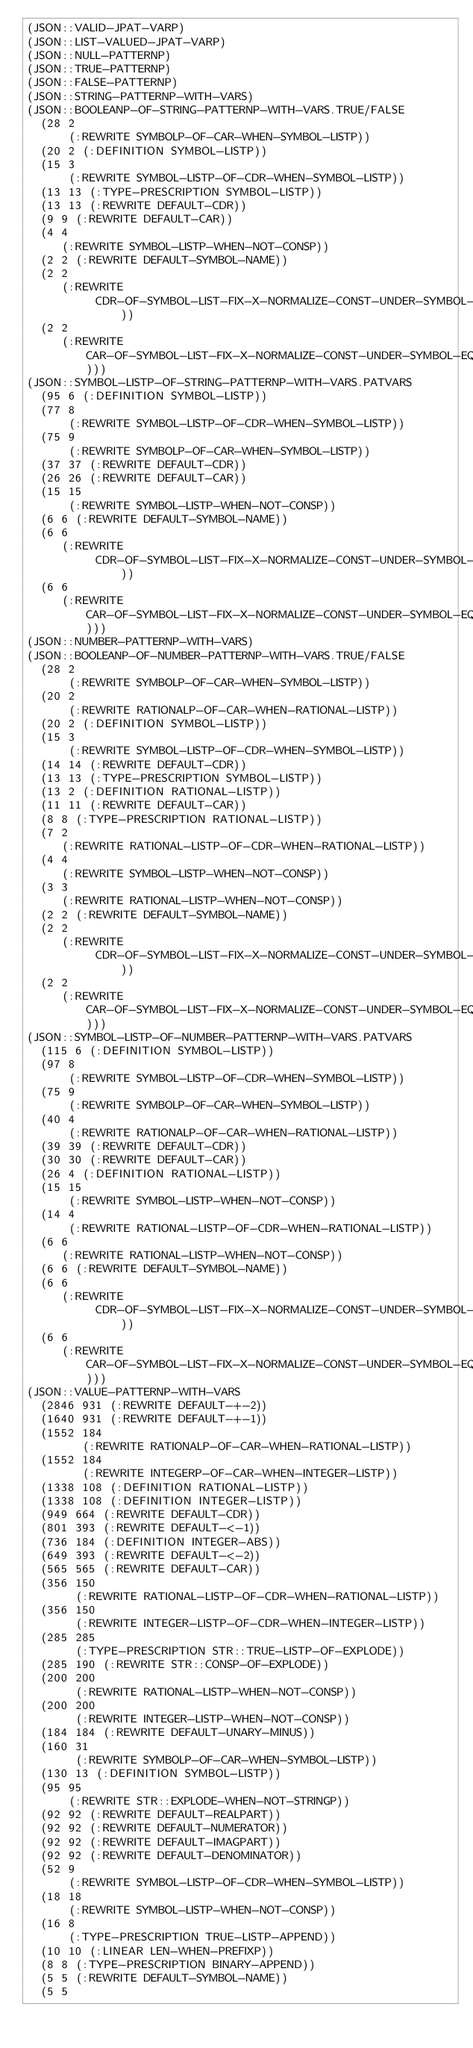Convert code to text. <code><loc_0><loc_0><loc_500><loc_500><_Lisp_>(JSON::VALID-JPAT-VARP)
(JSON::LIST-VALUED-JPAT-VARP)
(JSON::NULL-PATTERNP)
(JSON::TRUE-PATTERNP)
(JSON::FALSE-PATTERNP)
(JSON::STRING-PATTERNP-WITH-VARS)
(JSON::BOOLEANP-OF-STRING-PATTERNP-WITH-VARS.TRUE/FALSE
  (28 2
      (:REWRITE SYMBOLP-OF-CAR-WHEN-SYMBOL-LISTP))
  (20 2 (:DEFINITION SYMBOL-LISTP))
  (15 3
      (:REWRITE SYMBOL-LISTP-OF-CDR-WHEN-SYMBOL-LISTP))
  (13 13 (:TYPE-PRESCRIPTION SYMBOL-LISTP))
  (13 13 (:REWRITE DEFAULT-CDR))
  (9 9 (:REWRITE DEFAULT-CAR))
  (4 4
     (:REWRITE SYMBOL-LISTP-WHEN-NOT-CONSP))
  (2 2 (:REWRITE DEFAULT-SYMBOL-NAME))
  (2 2
     (:REWRITE
          CDR-OF-SYMBOL-LIST-FIX-X-NORMALIZE-CONST-UNDER-SYMBOL-LIST-EQUIV))
  (2 2
     (:REWRITE CAR-OF-SYMBOL-LIST-FIX-X-NORMALIZE-CONST-UNDER-SYMBOL-EQUIV)))
(JSON::SYMBOL-LISTP-OF-STRING-PATTERNP-WITH-VARS.PATVARS
  (95 6 (:DEFINITION SYMBOL-LISTP))
  (77 8
      (:REWRITE SYMBOL-LISTP-OF-CDR-WHEN-SYMBOL-LISTP))
  (75 9
      (:REWRITE SYMBOLP-OF-CAR-WHEN-SYMBOL-LISTP))
  (37 37 (:REWRITE DEFAULT-CDR))
  (26 26 (:REWRITE DEFAULT-CAR))
  (15 15
      (:REWRITE SYMBOL-LISTP-WHEN-NOT-CONSP))
  (6 6 (:REWRITE DEFAULT-SYMBOL-NAME))
  (6 6
     (:REWRITE
          CDR-OF-SYMBOL-LIST-FIX-X-NORMALIZE-CONST-UNDER-SYMBOL-LIST-EQUIV))
  (6 6
     (:REWRITE CAR-OF-SYMBOL-LIST-FIX-X-NORMALIZE-CONST-UNDER-SYMBOL-EQUIV)))
(JSON::NUMBER-PATTERNP-WITH-VARS)
(JSON::BOOLEANP-OF-NUMBER-PATTERNP-WITH-VARS.TRUE/FALSE
  (28 2
      (:REWRITE SYMBOLP-OF-CAR-WHEN-SYMBOL-LISTP))
  (20 2
      (:REWRITE RATIONALP-OF-CAR-WHEN-RATIONAL-LISTP))
  (20 2 (:DEFINITION SYMBOL-LISTP))
  (15 3
      (:REWRITE SYMBOL-LISTP-OF-CDR-WHEN-SYMBOL-LISTP))
  (14 14 (:REWRITE DEFAULT-CDR))
  (13 13 (:TYPE-PRESCRIPTION SYMBOL-LISTP))
  (13 2 (:DEFINITION RATIONAL-LISTP))
  (11 11 (:REWRITE DEFAULT-CAR))
  (8 8 (:TYPE-PRESCRIPTION RATIONAL-LISTP))
  (7 2
     (:REWRITE RATIONAL-LISTP-OF-CDR-WHEN-RATIONAL-LISTP))
  (4 4
     (:REWRITE SYMBOL-LISTP-WHEN-NOT-CONSP))
  (3 3
     (:REWRITE RATIONAL-LISTP-WHEN-NOT-CONSP))
  (2 2 (:REWRITE DEFAULT-SYMBOL-NAME))
  (2 2
     (:REWRITE
          CDR-OF-SYMBOL-LIST-FIX-X-NORMALIZE-CONST-UNDER-SYMBOL-LIST-EQUIV))
  (2 2
     (:REWRITE CAR-OF-SYMBOL-LIST-FIX-X-NORMALIZE-CONST-UNDER-SYMBOL-EQUIV)))
(JSON::SYMBOL-LISTP-OF-NUMBER-PATTERNP-WITH-VARS.PATVARS
  (115 6 (:DEFINITION SYMBOL-LISTP))
  (97 8
      (:REWRITE SYMBOL-LISTP-OF-CDR-WHEN-SYMBOL-LISTP))
  (75 9
      (:REWRITE SYMBOLP-OF-CAR-WHEN-SYMBOL-LISTP))
  (40 4
      (:REWRITE RATIONALP-OF-CAR-WHEN-RATIONAL-LISTP))
  (39 39 (:REWRITE DEFAULT-CDR))
  (30 30 (:REWRITE DEFAULT-CAR))
  (26 4 (:DEFINITION RATIONAL-LISTP))
  (15 15
      (:REWRITE SYMBOL-LISTP-WHEN-NOT-CONSP))
  (14 4
      (:REWRITE RATIONAL-LISTP-OF-CDR-WHEN-RATIONAL-LISTP))
  (6 6
     (:REWRITE RATIONAL-LISTP-WHEN-NOT-CONSP))
  (6 6 (:REWRITE DEFAULT-SYMBOL-NAME))
  (6 6
     (:REWRITE
          CDR-OF-SYMBOL-LIST-FIX-X-NORMALIZE-CONST-UNDER-SYMBOL-LIST-EQUIV))
  (6 6
     (:REWRITE CAR-OF-SYMBOL-LIST-FIX-X-NORMALIZE-CONST-UNDER-SYMBOL-EQUIV)))
(JSON::VALUE-PATTERNP-WITH-VARS
  (2846 931 (:REWRITE DEFAULT-+-2))
  (1640 931 (:REWRITE DEFAULT-+-1))
  (1552 184
        (:REWRITE RATIONALP-OF-CAR-WHEN-RATIONAL-LISTP))
  (1552 184
        (:REWRITE INTEGERP-OF-CAR-WHEN-INTEGER-LISTP))
  (1338 108 (:DEFINITION RATIONAL-LISTP))
  (1338 108 (:DEFINITION INTEGER-LISTP))
  (949 664 (:REWRITE DEFAULT-CDR))
  (801 393 (:REWRITE DEFAULT-<-1))
  (736 184 (:DEFINITION INTEGER-ABS))
  (649 393 (:REWRITE DEFAULT-<-2))
  (565 565 (:REWRITE DEFAULT-CAR))
  (356 150
       (:REWRITE RATIONAL-LISTP-OF-CDR-WHEN-RATIONAL-LISTP))
  (356 150
       (:REWRITE INTEGER-LISTP-OF-CDR-WHEN-INTEGER-LISTP))
  (285 285
       (:TYPE-PRESCRIPTION STR::TRUE-LISTP-OF-EXPLODE))
  (285 190 (:REWRITE STR::CONSP-OF-EXPLODE))
  (200 200
       (:REWRITE RATIONAL-LISTP-WHEN-NOT-CONSP))
  (200 200
       (:REWRITE INTEGER-LISTP-WHEN-NOT-CONSP))
  (184 184 (:REWRITE DEFAULT-UNARY-MINUS))
  (160 31
       (:REWRITE SYMBOLP-OF-CAR-WHEN-SYMBOL-LISTP))
  (130 13 (:DEFINITION SYMBOL-LISTP))
  (95 95
      (:REWRITE STR::EXPLODE-WHEN-NOT-STRINGP))
  (92 92 (:REWRITE DEFAULT-REALPART))
  (92 92 (:REWRITE DEFAULT-NUMERATOR))
  (92 92 (:REWRITE DEFAULT-IMAGPART))
  (92 92 (:REWRITE DEFAULT-DENOMINATOR))
  (52 9
      (:REWRITE SYMBOL-LISTP-OF-CDR-WHEN-SYMBOL-LISTP))
  (18 18
      (:REWRITE SYMBOL-LISTP-WHEN-NOT-CONSP))
  (16 8
      (:TYPE-PRESCRIPTION TRUE-LISTP-APPEND))
  (10 10 (:LINEAR LEN-WHEN-PREFIXP))
  (8 8 (:TYPE-PRESCRIPTION BINARY-APPEND))
  (5 5 (:REWRITE DEFAULT-SYMBOL-NAME))
  (5 5</code> 